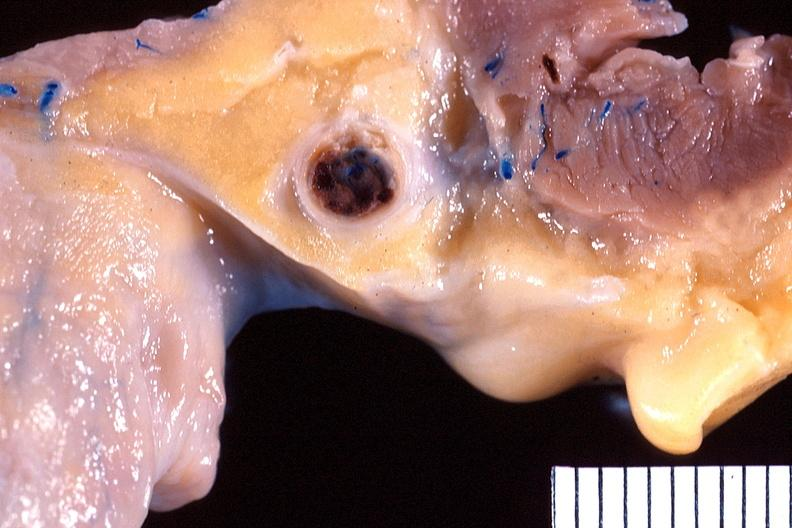where is this?
Answer the question using a single word or phrase. Heart 